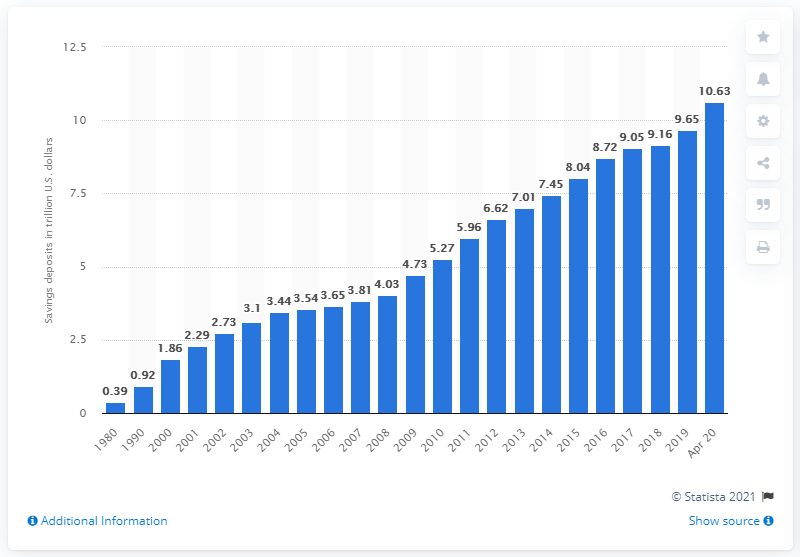Highlight a few significant elements in this photo. In 1980, the value of savings deposits at all U.S. depository institutions was approximately $0.39 trillion in dollars. As of April 2020, the value of savings deposits at all U.S. depository institutions was 10.63 trillion dollars. 